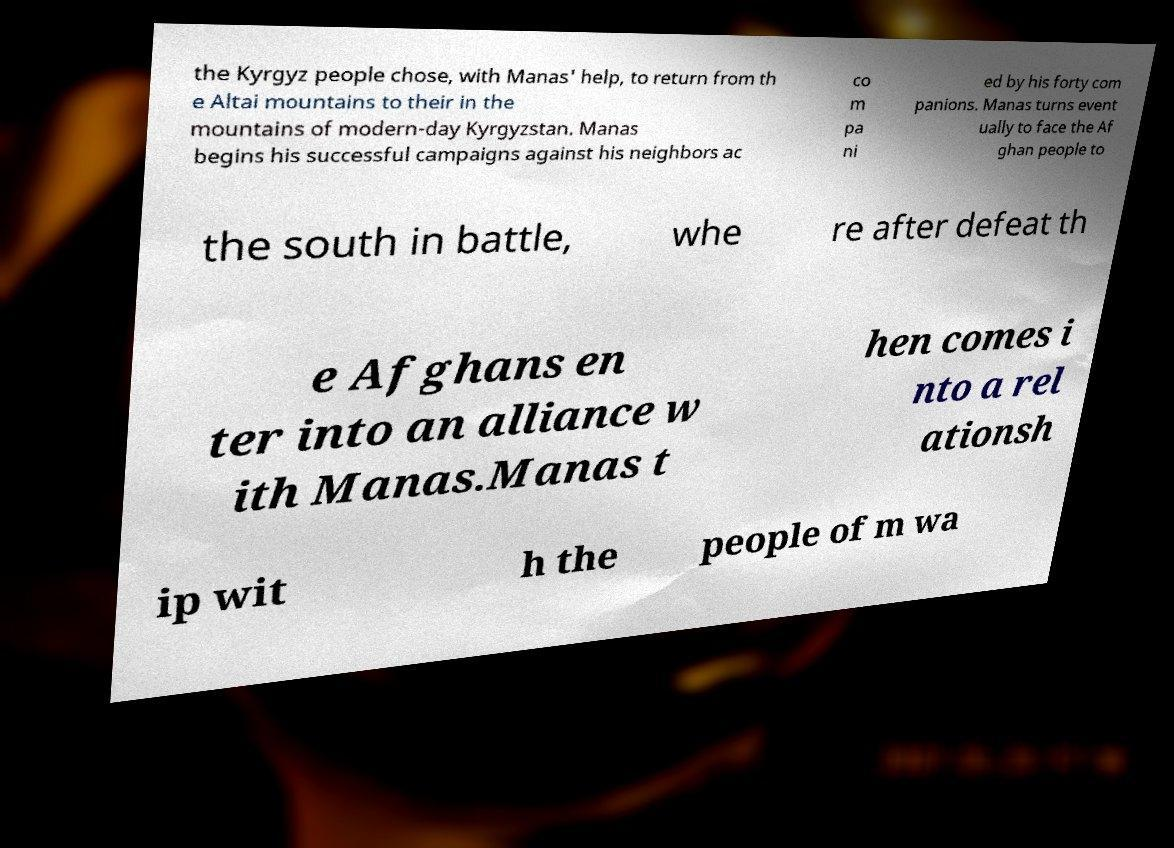Could you extract and type out the text from this image? the Kyrgyz people chose, with Manas' help, to return from th e Altai mountains to their in the mountains of modern-day Kyrgyzstan. Manas begins his successful campaigns against his neighbors ac co m pa ni ed by his forty com panions. Manas turns event ually to face the Af ghan people to the south in battle, whe re after defeat th e Afghans en ter into an alliance w ith Manas.Manas t hen comes i nto a rel ationsh ip wit h the people of m wa 